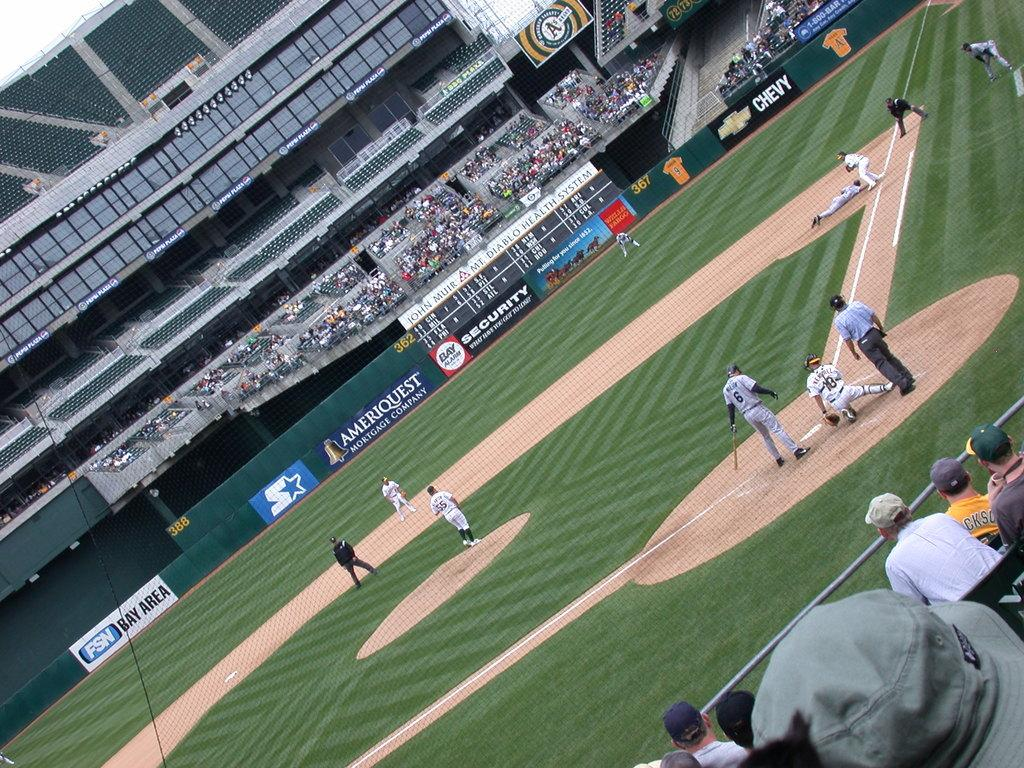<image>
Present a compact description of the photo's key features. Baseball Stadium with a sponsor board Ameriquest on green background. 